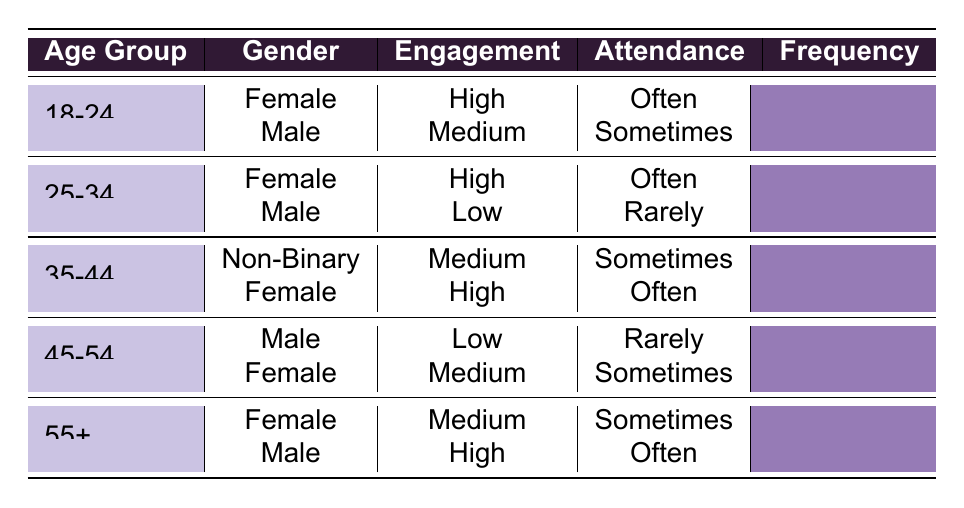What is the engagement level of Female attendees aged 18-24? According to the table, for the age group 18-24 and Gender Female, the Engagement Level is recorded as High
Answer: High How many Male attendees attend the shows rarely? By examining the table, we can see under the age group 45-54, there is one Male who has a Low engagement level and attends rarely. Therefore, there is a total of one Male attendee who participates rarely
Answer: 1 Is there a Non-Binary attendee in the 35-44 age group? Yes, the table shows that there is one Non-Binary attendee in the 35-44 age group, with a Medium engagement level and attending Sometimes
Answer: Yes What is the average engagement level of Female attendees across all age groups? For Female attendees: 18-24 (High), 25-34 (High), 35-44 (High), 45-54 (Medium), and 55+ (Medium). Assigning numerical values for engagement: High = 2, Medium = 1. Summing these: 2 + 2 + 2 + 1 + 1 = 8. There are 5 Female attendees, so the average is 8/5 = 1.6, which corresponds to an average engagement level slightly leaning toward Medium
Answer: 1.6 How many attendees aged 55+ have a High engagement level? The only instance from the table for attendees aged 55+ is a Male with High engagement level. So there is one attendee aged 55+ with a High engagement level
Answer: 1 Do Female attendees generally attend shows more often than Male attendees? To determine this, we need to assess the Attendance Frequency. Female totals: 18-24 (Often), 25-34 (Often), 35-44 (Often), 45-54 (Sometimes), 55+ (Sometimes), which is 3 Often and 2 Sometimes. Male totals: 18-24 (Sometimes), 25-34 (Rarely), 35-44 (Sometimes), 45-54 (Rarely), 55+ (Often), which is 1 Often, 3 Sometimes, and 2 Rarely. Females attend more frequently overall with a count of 3 Often versus Males only having 1
Answer: Yes What is the total count of attendees in the 25-34 age group? In the table, there are two entries for the 25-34 age group: one Female and one Male. Adding these gives a total of 2 attendees in this age group
Answer: 2 